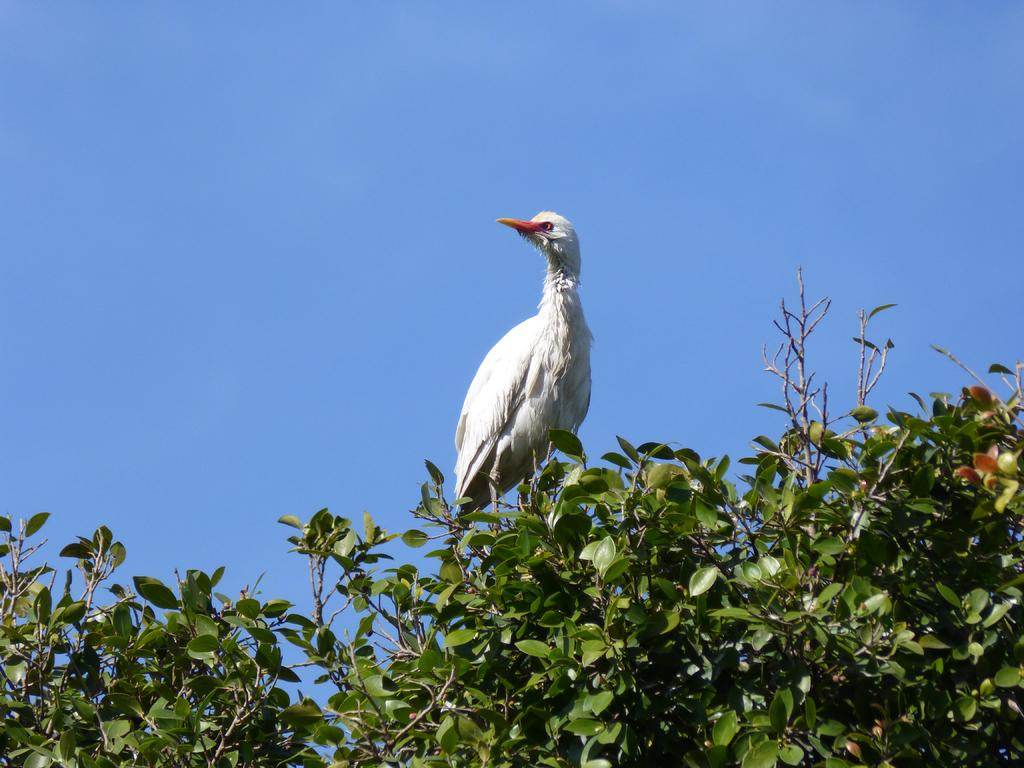What type of animal is in the picture? There is a white bird in the picture. Where is the bird located? The bird is on a tree. What is the color of the bird's beak? The bird has a long yellow beak. What can be seen in the background of the picture? The sky is visible in the background of the picture. What is the color of the sky in the image? The sky is blue in color. How many minutes does the bird spend sitting on the throne in the image? There is no throne present in the image, so the bird cannot spend any minutes sitting on it. 